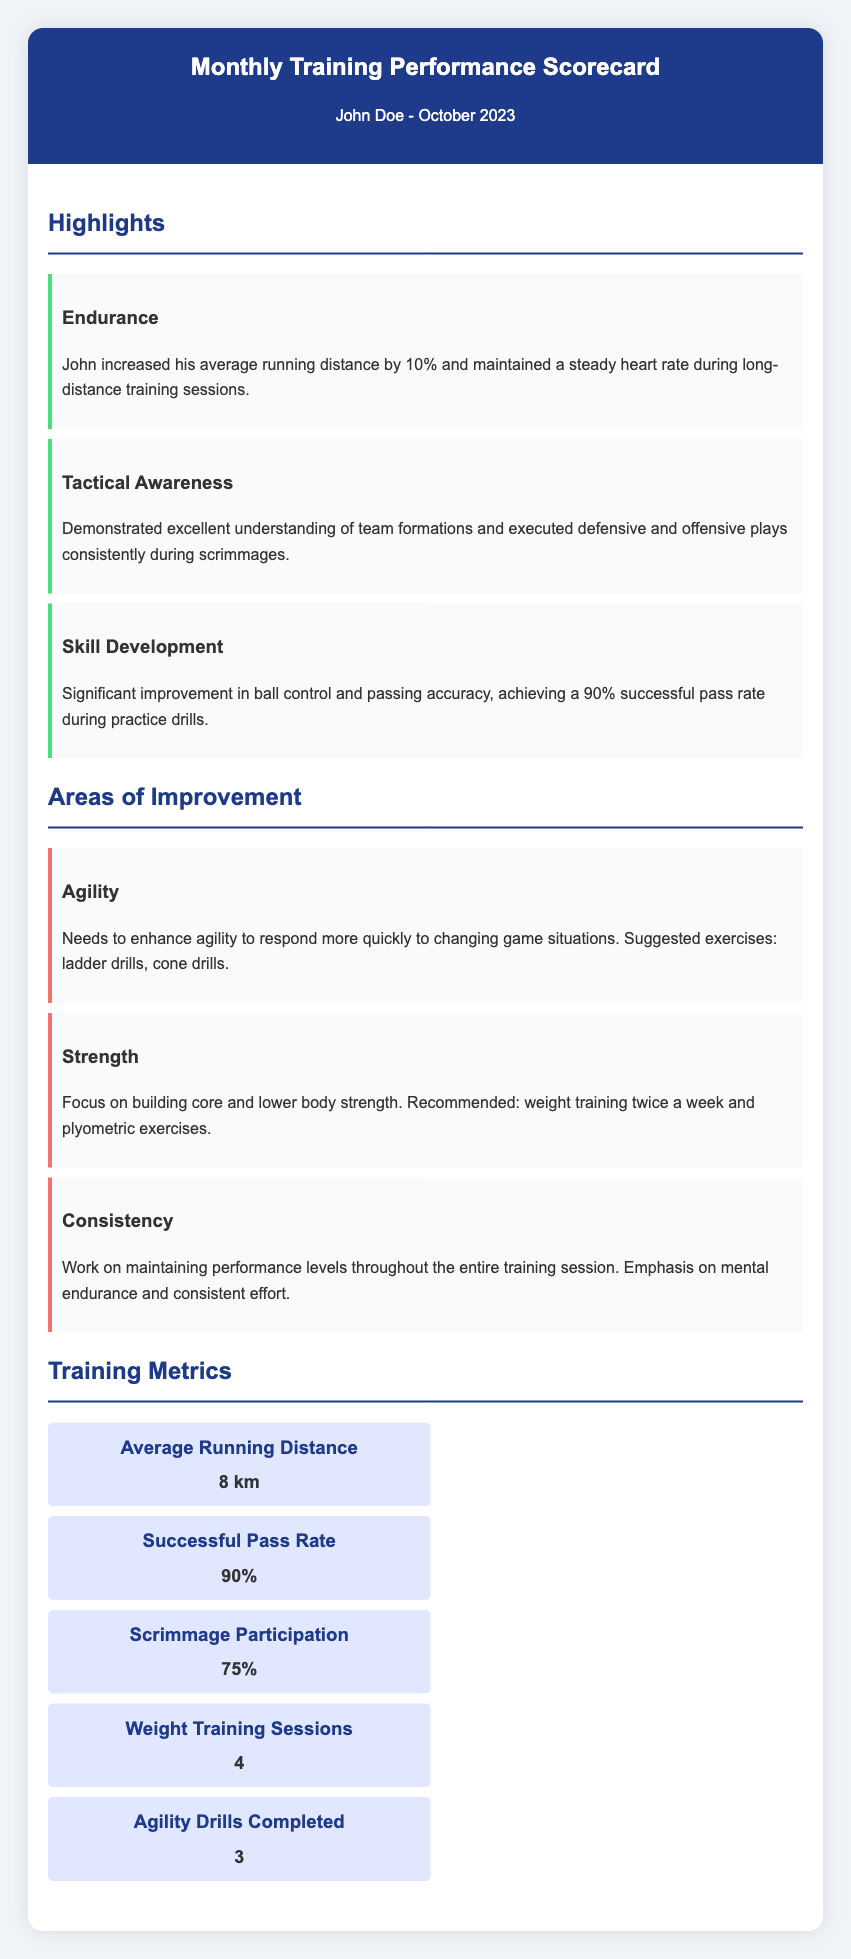what is John Doe's average running distance? The average running distance is mentioned in the training metrics section of the scorecard.
Answer: 8 km how much did John increase his average running distance by? The scorecard states that John increased his average running distance by a specific percentage.
Answer: 10% what percentage is John’s successful pass rate? The successful pass rate is listed under training metrics, providing a direct measure of his passing performance.
Answer: 90% what is recommended to improve John's strength? The scorecard discusses recommended actions for improving strength in the areas of training.
Answer: weight training twice a week which area does John need to improve to respond more quickly to game situations? The document identifies a specific skill that requires improvement regarding game responsiveness.
Answer: Agility how many weight training sessions did John complete? The number of weight training sessions is provided in the training metrics section of the scorecard.
Answer: 4 what does John need to work on to maintain performance levels? The scorecard specifies a mental aspect that affects performance consistency during training sessions.
Answer: mental endurance which skill saw a significant improvement during training? The scorecard highlights a particular skill that John developed effectively during his training.
Answer: Skill Development what was the participation rate in scrimmages? The scorecard lists the participation rate in scrimmage sessions, which is relevant to John’s practice engagement.
Answer: 75% 